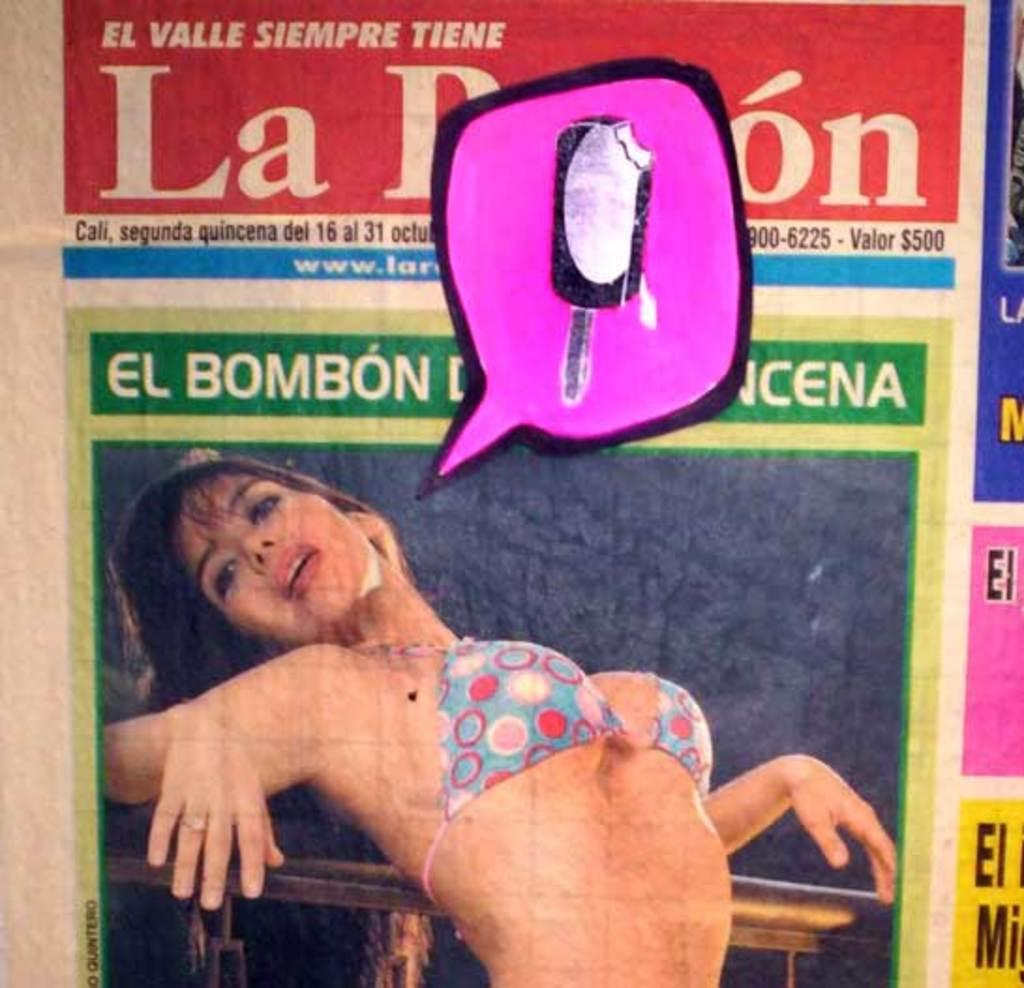What is present in the image that features an image of a person? There is a poster in the image that contains an image of a woman. What else can be found on the poster besides the image? There is text on the poster. Where is the toad sitting in the image? There is no toad present in the image. What type of page is depicted in the image? The image does not depict a page; it features a poster with an image of a woman and text. 